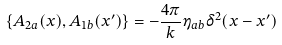<formula> <loc_0><loc_0><loc_500><loc_500>\{ A _ { 2 a } ( x ) , A _ { 1 b } ( x ^ { \prime } ) \} = - \frac { 4 \pi } { k } \eta _ { a b } \delta ^ { 2 } ( x - x ^ { \prime } )</formula> 